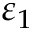Convert formula to latex. <formula><loc_0><loc_0><loc_500><loc_500>\varepsilon _ { 1 }</formula> 